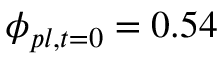Convert formula to latex. <formula><loc_0><loc_0><loc_500><loc_500>\phi _ { p l , t = 0 } = 0 . 5 4</formula> 